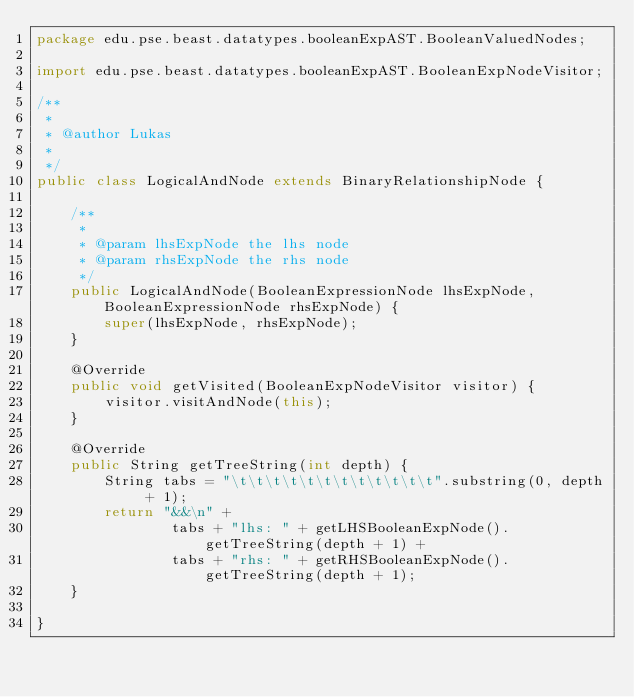Convert code to text. <code><loc_0><loc_0><loc_500><loc_500><_Java_>package edu.pse.beast.datatypes.booleanExpAST.BooleanValuedNodes;

import edu.pse.beast.datatypes.booleanExpAST.BooleanExpNodeVisitor;

/**
 * 
 * @author Lukas
 *
 */
public class LogicalAndNode extends BinaryRelationshipNode {

    /**
     * 
     * @param lhsExpNode the lhs node
     * @param rhsExpNode the rhs node
     */
    public LogicalAndNode(BooleanExpressionNode lhsExpNode, BooleanExpressionNode rhsExpNode) {
        super(lhsExpNode, rhsExpNode);
    }

    @Override
    public void getVisited(BooleanExpNodeVisitor visitor) {
        visitor.visitAndNode(this);
    }

    @Override
    public String getTreeString(int depth) {
        String tabs = "\t\t\t\t\t\t\t\t\t\t\t\t".substring(0, depth + 1);
        return "&&\n" +
                tabs + "lhs: " + getLHSBooleanExpNode().getTreeString(depth + 1) +
                tabs + "rhs: " + getRHSBooleanExpNode().getTreeString(depth + 1);
    }

}
</code> 